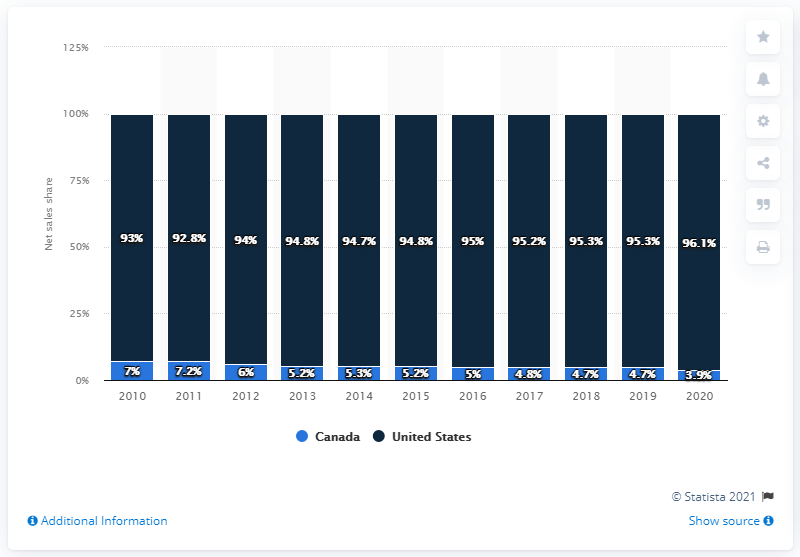Give some essential details in this illustration. In 2020, Samsonite's net sales in North America accounted for 96.1% of its total net sales, with the United States being the primary contributor to this market with a share of 92.5%. 